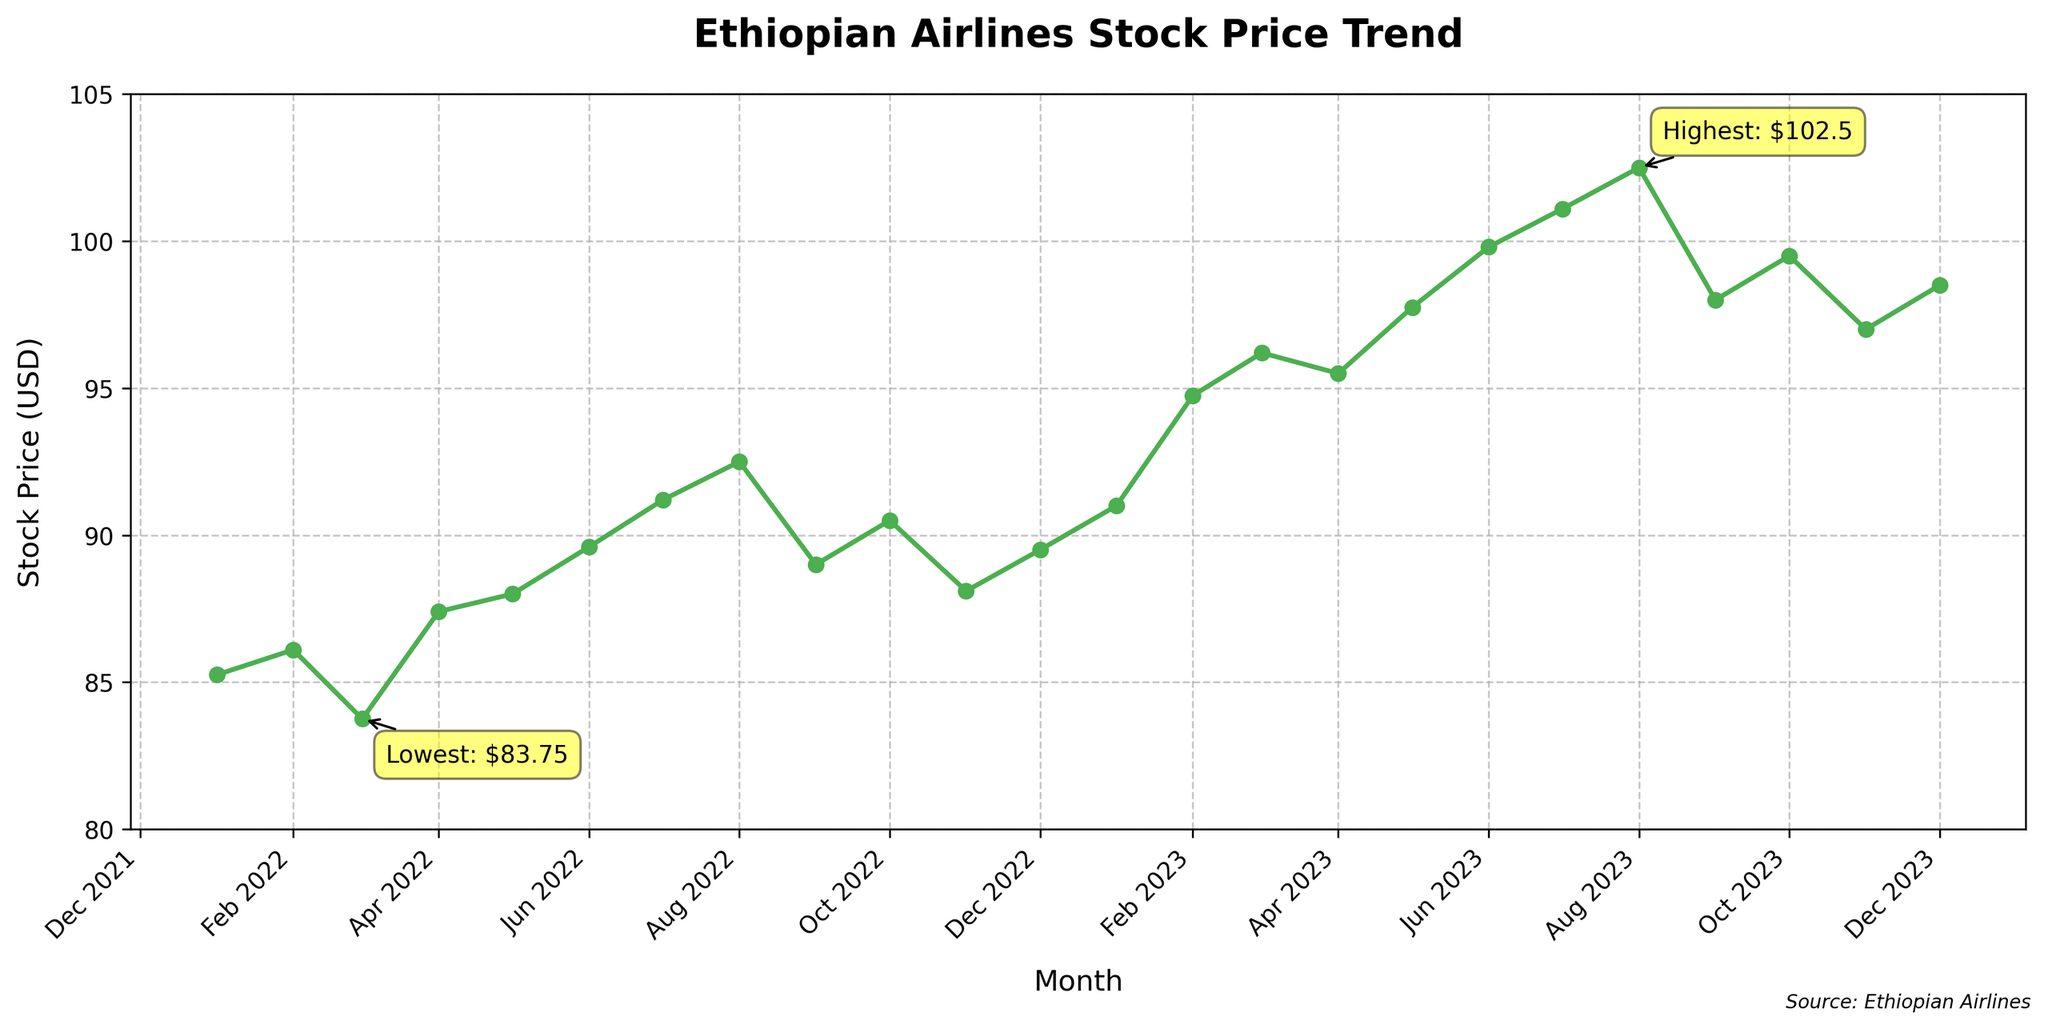What's the title of the figure? The title of the figure is typically located at the top of the chart or graph. It provides a summary of what the figure is depicting. In this case, the title is "Ethiopian Airlines Stock Price Trend".
Answer: Ethiopian Airlines Stock Price Trend How many months are represented in the figure? To determine the number of months, count the distinct data points along the x-axis, which are the months from January 2022 to December 2023.
Answer: 24 In which month did Ethiopian Airlines' stock price peak? Identify the highest point on the stock price trend line. The annotation on the figure specifies the month and value of the highest stock price.
Answer: August 2023 What was the lowest stock price attained, and in which month did it occur? Look for the lowest point on the stock price trend line. The annotation on the figure provides information about the month and value associated with the lowest stock price.
Answer: $83.75 in March 2022 How did the stock price trend between January 2022 and December 2023? Observe the general direction and fluctuations of the stock price line over the specified period. It shows the increase, decrease, or stability in the trend.
Answer: Overall, it trended upwards What is the average stock price across the entire period? Calculate the average by summing all the stock price values and dividing by the total number of months (24). Average = (sum of all stock prices) / 24. For example, (85.25 + 86.10 + ... + 98.50) / 24.
Answer: $92.98 Compare the stock prices of January 2022 and January 2023. Which was higher? Find and compare the values at the two specified months.
Answer: January 2023 was higher What is the general relationship between the trend in stock price and the regional tourism impact? Examine the stock price movement together with the annotated impact levels to see if periods of high or very high impact correlate with increases in stock price.
Answer: Positive correlation During which month between 2022 and 2023 did the stock price first cross $95? Identify the month on the x-axis where the stock price line first reaches or surpasses $95.
Answer: March 2023 How did the stock price change from February 2023 to March 2023? Compare the stock price values for February 2023 and March 2023.
Answer: Increased 